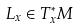Convert formula to latex. <formula><loc_0><loc_0><loc_500><loc_500>L _ { x } \in T _ { x } ^ { * } M</formula> 